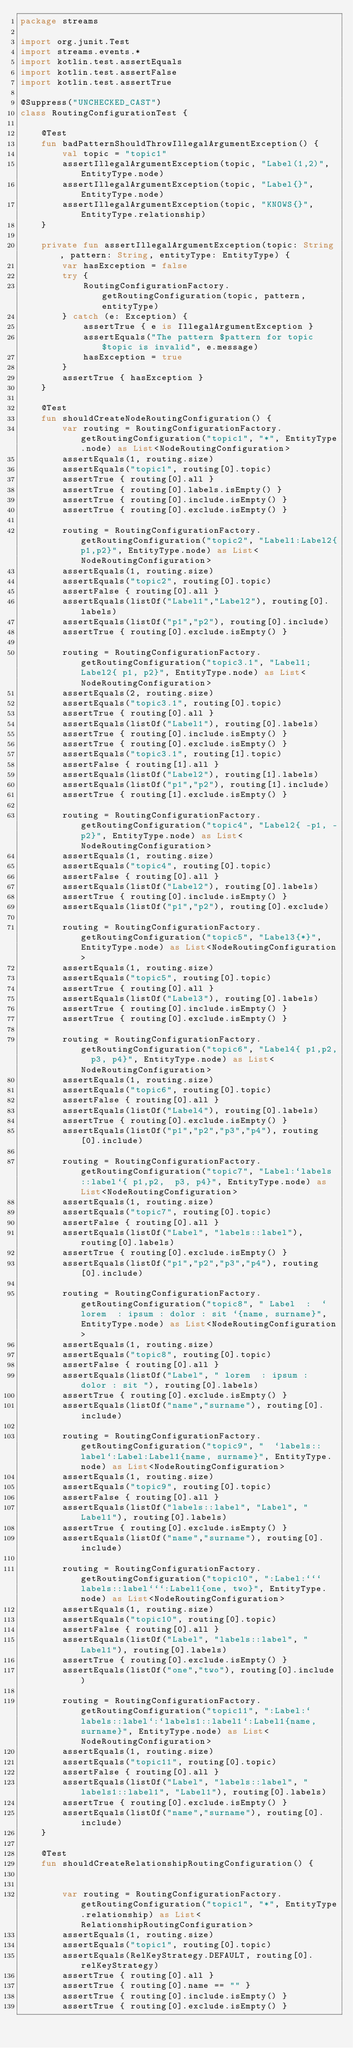Convert code to text. <code><loc_0><loc_0><loc_500><loc_500><_Kotlin_>package streams

import org.junit.Test
import streams.events.*
import kotlin.test.assertEquals
import kotlin.test.assertFalse
import kotlin.test.assertTrue

@Suppress("UNCHECKED_CAST")
class RoutingConfigurationTest {

    @Test
    fun badPatternShouldThrowIllegalArgumentException() {
        val topic = "topic1"
        assertIllegalArgumentException(topic, "Label(1,2)", EntityType.node)
        assertIllegalArgumentException(topic, "Label{}", EntityType.node)
        assertIllegalArgumentException(topic, "KNOWS{}", EntityType.relationship)
    }

    private fun assertIllegalArgumentException(topic: String, pattern: String, entityType: EntityType) {
        var hasException = false
        try {
            RoutingConfigurationFactory.getRoutingConfiguration(topic, pattern, entityType)
        } catch (e: Exception) {
            assertTrue { e is IllegalArgumentException }
            assertEquals("The pattern $pattern for topic $topic is invalid", e.message)
            hasException = true
        }
        assertTrue { hasException }
    }

    @Test
    fun shouldCreateNodeRoutingConfiguration() {
        var routing = RoutingConfigurationFactory.getRoutingConfiguration("topic1", "*", EntityType.node) as List<NodeRoutingConfiguration>
        assertEquals(1, routing.size)
        assertEquals("topic1", routing[0].topic)
        assertTrue { routing[0].all }
        assertTrue { routing[0].labels.isEmpty() }
        assertTrue { routing[0].include.isEmpty() }
        assertTrue { routing[0].exclude.isEmpty() }

        routing = RoutingConfigurationFactory.getRoutingConfiguration("topic2", "Label1:Label2{p1,p2}", EntityType.node) as List<NodeRoutingConfiguration>
        assertEquals(1, routing.size)
        assertEquals("topic2", routing[0].topic)
        assertFalse { routing[0].all }
        assertEquals(listOf("Label1","Label2"), routing[0].labels)
        assertEquals(listOf("p1","p2"), routing[0].include)
        assertTrue { routing[0].exclude.isEmpty() }
        
        routing = RoutingConfigurationFactory.getRoutingConfiguration("topic3.1", "Label1;Label2{ p1, p2}", EntityType.node) as List<NodeRoutingConfiguration>
        assertEquals(2, routing.size)
        assertEquals("topic3.1", routing[0].topic)
        assertTrue { routing[0].all }
        assertEquals(listOf("Label1"), routing[0].labels)
        assertTrue { routing[0].include.isEmpty() }
        assertTrue { routing[0].exclude.isEmpty() }
        assertEquals("topic3.1", routing[1].topic)
        assertFalse { routing[1].all }
        assertEquals(listOf("Label2"), routing[1].labels)
        assertEquals(listOf("p1","p2"), routing[1].include)
        assertTrue { routing[1].exclude.isEmpty() }

        routing = RoutingConfigurationFactory.getRoutingConfiguration("topic4", "Label2{ -p1, -p2}", EntityType.node) as List<NodeRoutingConfiguration>
        assertEquals(1, routing.size)
        assertEquals("topic4", routing[0].topic)
        assertFalse { routing[0].all }
        assertEquals(listOf("Label2"), routing[0].labels)
        assertTrue { routing[0].include.isEmpty() }
        assertEquals(listOf("p1","p2"), routing[0].exclude)

        routing = RoutingConfigurationFactory.getRoutingConfiguration("topic5", "Label3{*}", EntityType.node) as List<NodeRoutingConfiguration>
        assertEquals(1, routing.size)
        assertEquals("topic5", routing[0].topic)
        assertTrue { routing[0].all }
        assertEquals(listOf("Label3"), routing[0].labels)
        assertTrue { routing[0].include.isEmpty() }
        assertTrue { routing[0].exclude.isEmpty() }

        routing = RoutingConfigurationFactory.getRoutingConfiguration("topic6", "Label4{ p1,p2,  p3, p4}", EntityType.node) as List<NodeRoutingConfiguration>
        assertEquals(1, routing.size)
        assertEquals("topic6", routing[0].topic)
        assertFalse { routing[0].all }
        assertEquals(listOf("Label4"), routing[0].labels)
        assertTrue { routing[0].exclude.isEmpty() }
        assertEquals(listOf("p1","p2","p3","p4"), routing[0].include)

        routing = RoutingConfigurationFactory.getRoutingConfiguration("topic7", "Label:`labels::label`{ p1,p2,  p3, p4}", EntityType.node) as List<NodeRoutingConfiguration>
        assertEquals(1, routing.size)
        assertEquals("topic7", routing[0].topic)
        assertFalse { routing[0].all }
        assertEquals(listOf("Label", "labels::label"), routing[0].labels)
        assertTrue { routing[0].exclude.isEmpty() }
        assertEquals(listOf("p1","p2","p3","p4"), routing[0].include)

        routing = RoutingConfigurationFactory.getRoutingConfiguration("topic8", " Label  :  ` lorem  : ipsum : dolor : sit `{name, surname}", EntityType.node) as List<NodeRoutingConfiguration>
        assertEquals(1, routing.size)
        assertEquals("topic8", routing[0].topic)
        assertFalse { routing[0].all }
        assertEquals(listOf("Label", " lorem  : ipsum : dolor : sit "), routing[0].labels)
        assertTrue { routing[0].exclude.isEmpty() }
        assertEquals(listOf("name","surname"), routing[0].include)

        routing = RoutingConfigurationFactory.getRoutingConfiguration("topic9", "  `labels::label`:Label:Label1{name, surname}", EntityType.node) as List<NodeRoutingConfiguration>
        assertEquals(1, routing.size)
        assertEquals("topic9", routing[0].topic)
        assertFalse { routing[0].all }
        assertEquals(listOf("labels::label", "Label", "Label1"), routing[0].labels)
        assertTrue { routing[0].exclude.isEmpty() }
        assertEquals(listOf("name","surname"), routing[0].include)

        routing = RoutingConfigurationFactory.getRoutingConfiguration("topic10", ":Label:```labels::label```:Label1{one, two}", EntityType.node) as List<NodeRoutingConfiguration>
        assertEquals(1, routing.size)
        assertEquals("topic10", routing[0].topic)
        assertFalse { routing[0].all }
        assertEquals(listOf("Label", "labels::label", "Label1"), routing[0].labels)
        assertTrue { routing[0].exclude.isEmpty() }
        assertEquals(listOf("one","two"), routing[0].include)

        routing = RoutingConfigurationFactory.getRoutingConfiguration("topic11", ":Label:`labels::label`:`labels1::label1`:Label1{name, surname}", EntityType.node) as List<NodeRoutingConfiguration>
        assertEquals(1, routing.size)
        assertEquals("topic11", routing[0].topic)
        assertFalse { routing[0].all }
        assertEquals(listOf("Label", "labels::label", "labels1::label1", "Label1"), routing[0].labels)
        assertTrue { routing[0].exclude.isEmpty() }
        assertEquals(listOf("name","surname"), routing[0].include)
    }

    @Test
    fun shouldCreateRelationshipRoutingConfiguration() {


        var routing = RoutingConfigurationFactory.getRoutingConfiguration("topic1", "*", EntityType.relationship) as List<RelationshipRoutingConfiguration>
        assertEquals(1, routing.size)
        assertEquals("topic1", routing[0].topic)
        assertEquals(RelKeyStrategy.DEFAULT, routing[0].relKeyStrategy)
        assertTrue { routing[0].all }
        assertTrue { routing[0].name == "" }
        assertTrue { routing[0].include.isEmpty() }
        assertTrue { routing[0].exclude.isEmpty() }

</code> 